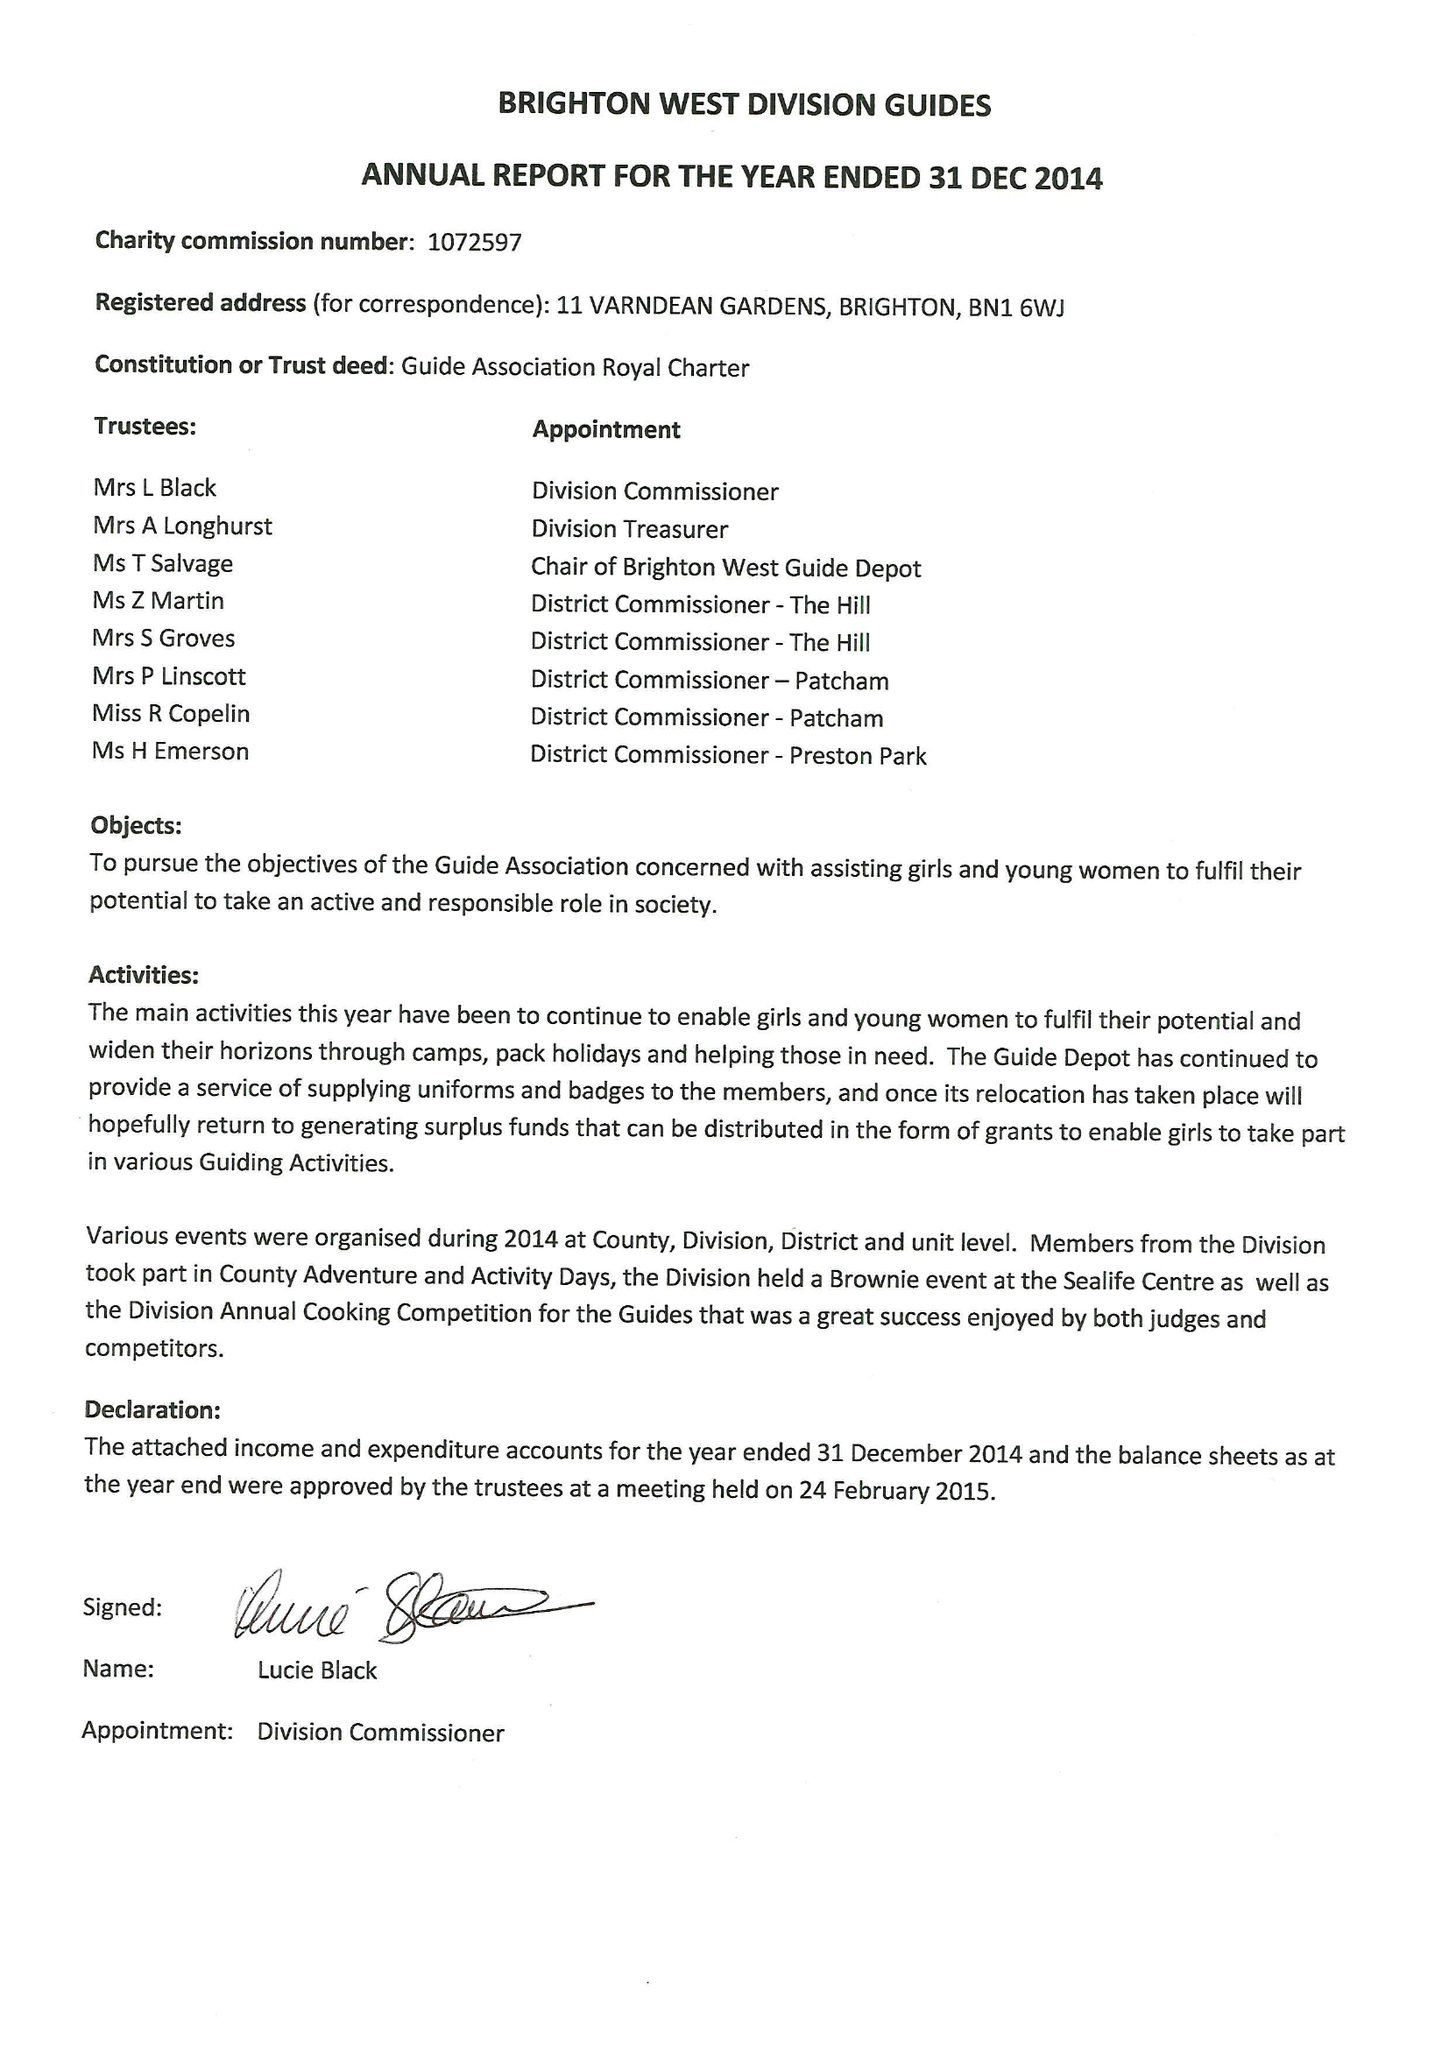What is the value for the address__street_line?
Answer the question using a single word or phrase. 11 VARNDEAN GARDENS 